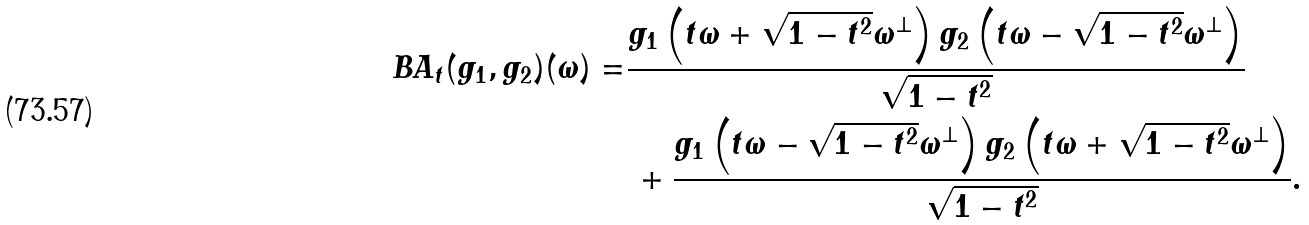Convert formula to latex. <formula><loc_0><loc_0><loc_500><loc_500>B A _ { t } ( g _ { 1 } , g _ { 2 } ) ( \omega ) = & \frac { g _ { 1 } \left ( t \omega + \sqrt { 1 - t ^ { 2 } } \omega ^ { \perp } \right ) g _ { 2 } \left ( t \omega - \sqrt { 1 - t ^ { 2 } } \omega ^ { \perp } \right ) } { \sqrt { 1 - t ^ { 2 } } } \\ & \, + \frac { g _ { 1 } \left ( t \omega - \sqrt { 1 - t ^ { 2 } } \omega ^ { \perp } \right ) g _ { 2 } \left ( t \omega + \sqrt { 1 - t ^ { 2 } } \omega ^ { \perp } \right ) } { \sqrt { 1 - t ^ { 2 } } } .</formula> 